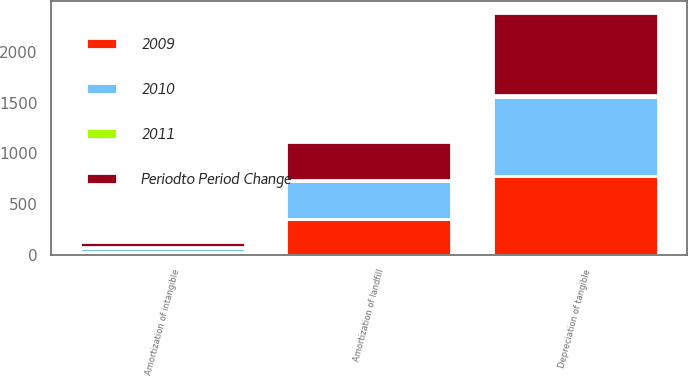Convert chart. <chart><loc_0><loc_0><loc_500><loc_500><stacked_bar_chart><ecel><fcel>Depreciation of tangible<fcel>Amortization of landfill<fcel>Amortization of intangible<nl><fcel>Periodto Period Change<fcel>800<fcel>378<fcel>51<nl><fcel>2011<fcel>19<fcel>6<fcel>10<nl><fcel>2010<fcel>781<fcel>372<fcel>41<nl><fcel>2009<fcel>779<fcel>358<fcel>29<nl></chart> 